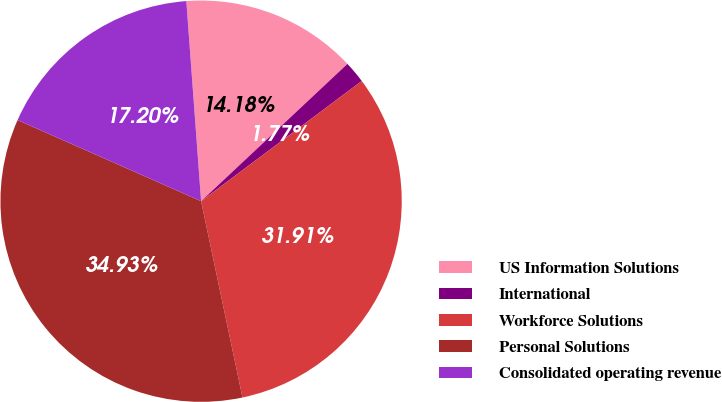Convert chart to OTSL. <chart><loc_0><loc_0><loc_500><loc_500><pie_chart><fcel>US Information Solutions<fcel>International<fcel>Workforce Solutions<fcel>Personal Solutions<fcel>Consolidated operating revenue<nl><fcel>14.18%<fcel>1.77%<fcel>31.91%<fcel>34.93%<fcel>17.2%<nl></chart> 